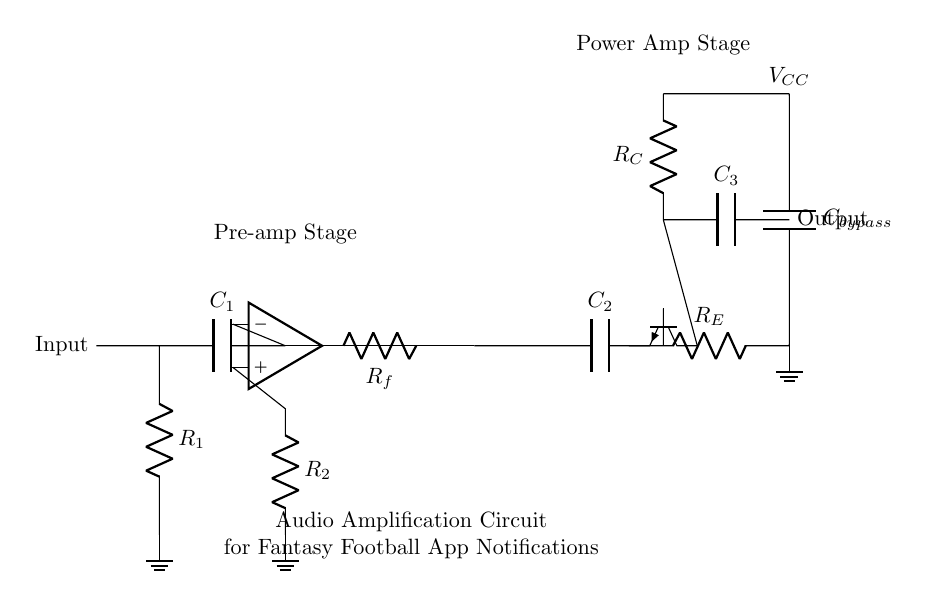What is the first component in the input stage? The first component in the input stage is a capacitor labeled C1, which is connected directly to the input signal line.
Answer: C1 What is the purpose of the resistor labeled Rf? The resistor Rf is in the feedback loop of the operational amplifier, which helps control the gain of the amplifier by providing a path for part of the output signal to be fed back to the input.
Answer: Feedback gain control What is the voltage supply connected to the circuit? The voltage supply connected to the circuit is labeled as Vcc, indicating the positive voltage provided for the power amplifier stage.
Answer: Vcc How many capacitors are used in the circuit? There are four capacitors used in total: C1, C2, C3, and Cbypass, each serving different functions in the amplification process.
Answer: Four What does the label ‘Pre-amp Stage’ indicate? The label ‘Pre-amp Stage’ indicates the portion of the circuit responsible for the initial amplification of the audio signal before it is further amplified by the main power amplifier stage.
Answer: Initial amplification What is the role of the resistor labeled R2? The resistor R2 is connected to the inverting input of the operational amplifier and is part of a voltage divider that helps set the reference level for the input signal to achieve the desired amplification.
Answer: Sets reference level What component type is Q1 in the output stage? Q1 is an NPN transistor, which is used in the output stage to further amplify the audio signal to drive speakers or output devices effectively.
Answer: NPN transistor 